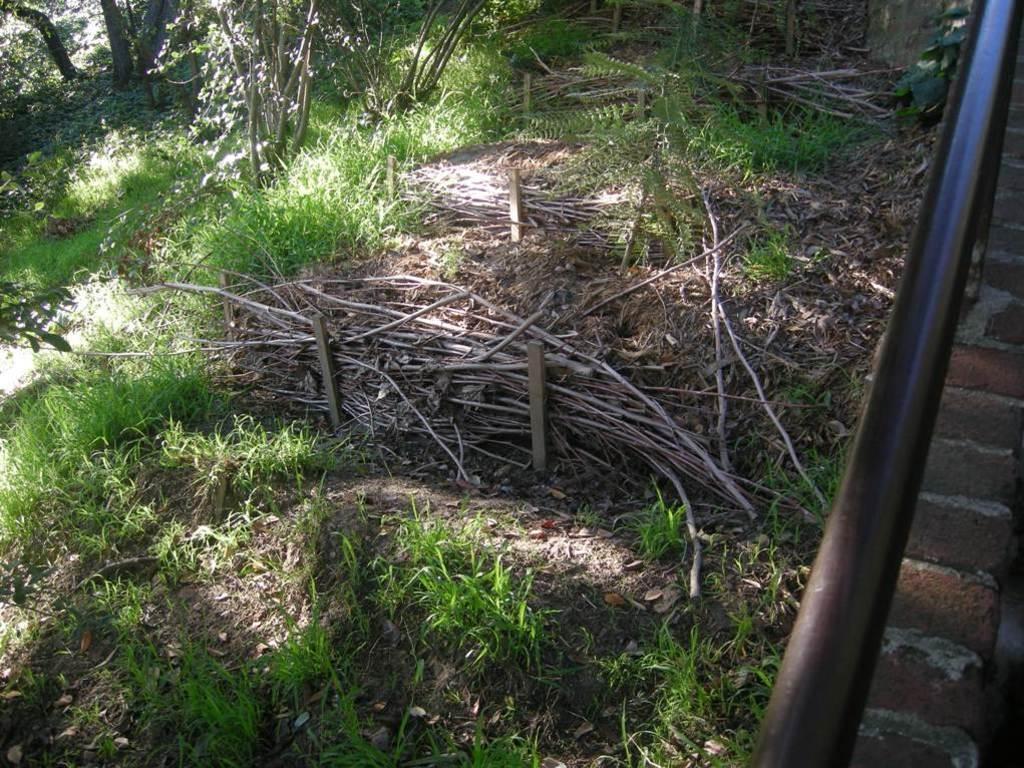Can you describe this image briefly? In this image, we can see plants, wooden objects and few things. On the right side of the image, we can see rod and brick wall. 